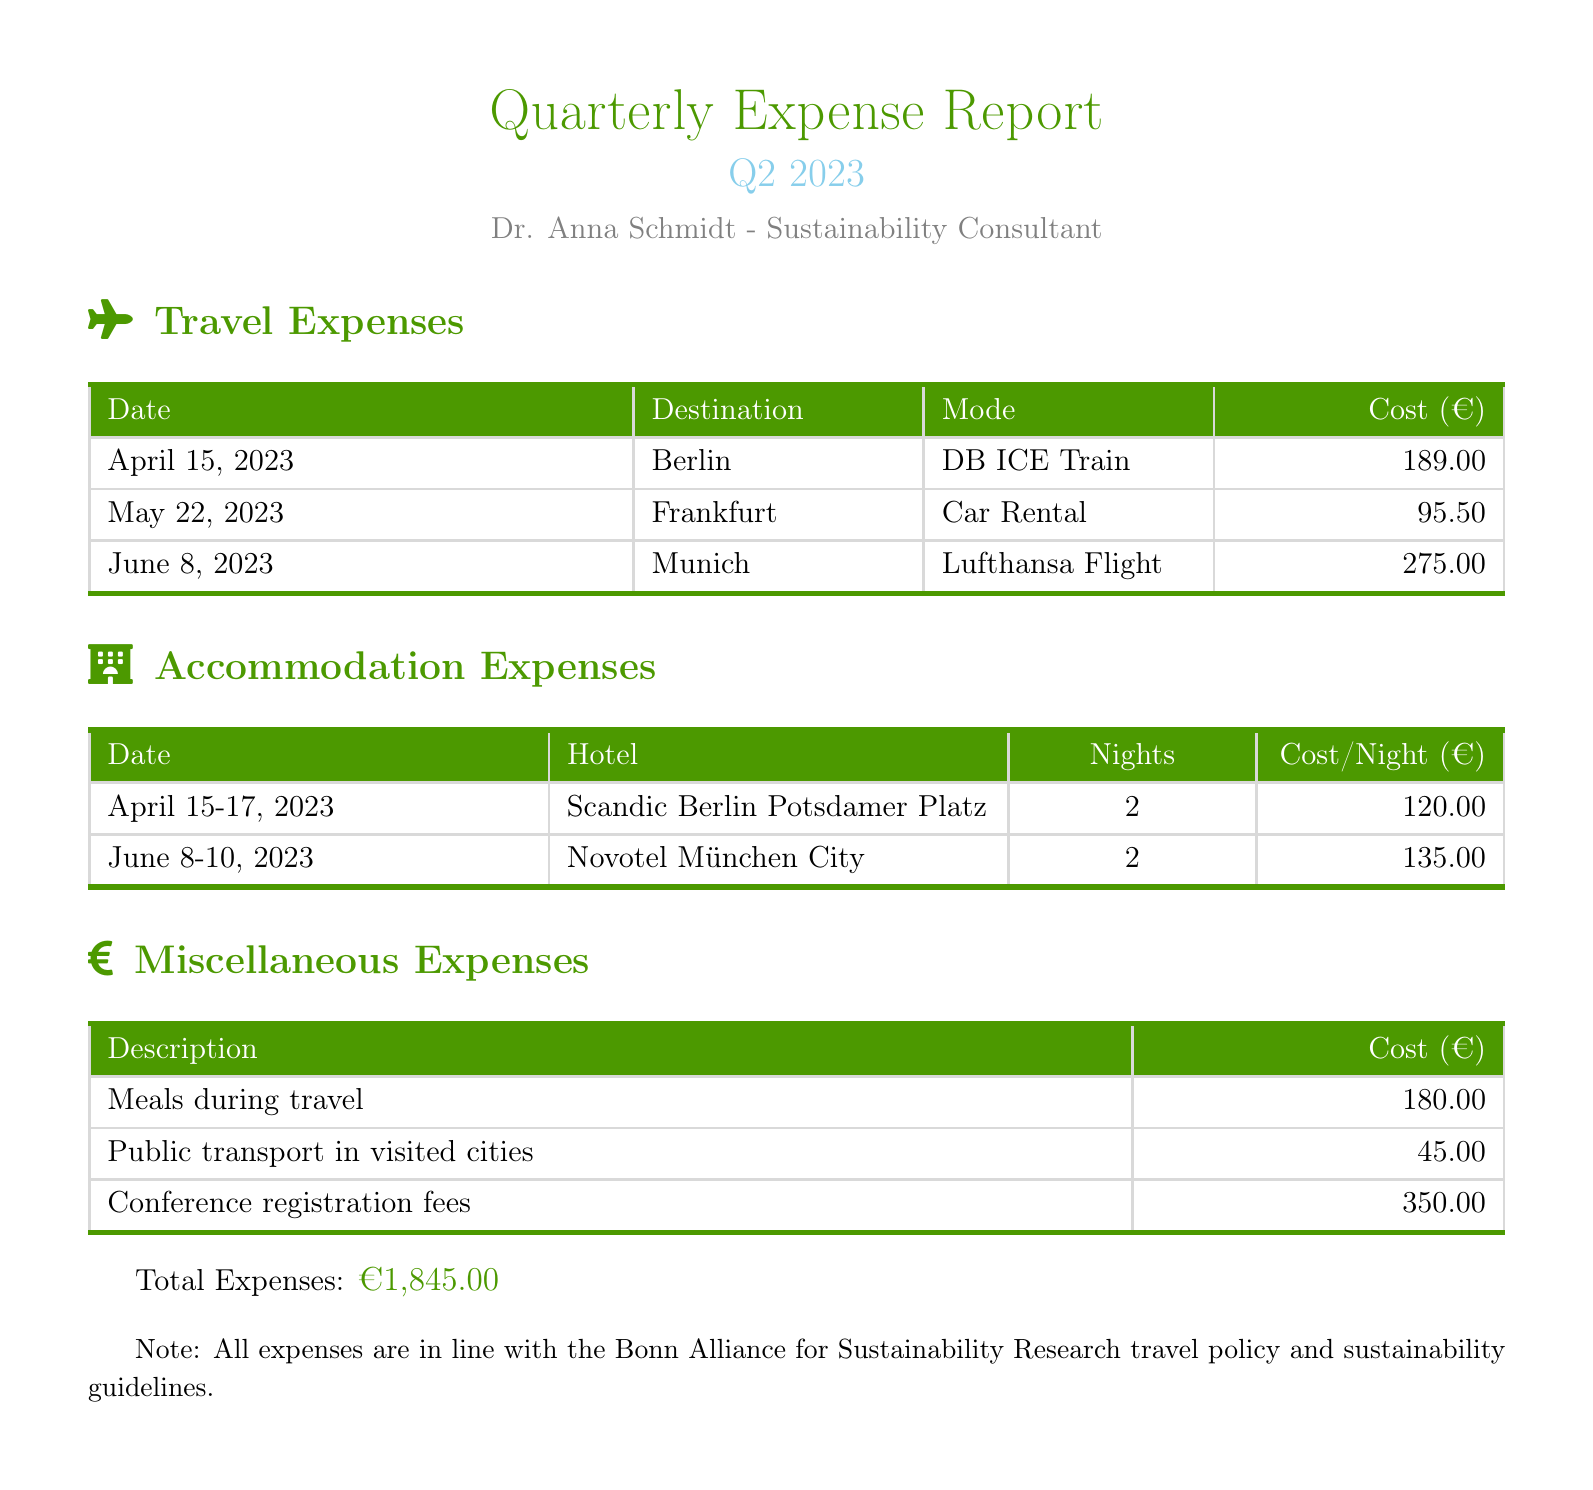What is the total cost of travel expenses? The total cost of travel expenses is the sum of all individual travel costs listed in the travel section: 189.00 + 95.50 + 275.00 = 559.50.
Answer: 559.00 What city was visited on April 15, 2023? April 15, 2023 is listed under the travel expenses for Berlin.
Answer: Berlin How many nights was accommodation booked in Munich? The accommodation section shows that 2 nights were booked for the hotel in Munich.
Answer: 2 What was the cost per night at the Novotel München City? The cost per night at Novotel München City is stated as 135.00.
Answer: 135.00 What was the total cost of miscellaneous expenses? The total cost of miscellaneous expenses is the sum of all costs listed under this section: 180.00 + 45.00 + 350.00 = 575.00.
Answer: 575.00 In which month did the most expensive travel expense occur? The highest individual travel expense listed is from June, specifically for the Lufthansa Flight.
Answer: June What was the total amount for accommodation expenses? The total amount for accommodation expenses is calculated by adding the costs of both hotel stays: 120.00 * 2 nights + 135.00 * 2 nights = 510.00.
Answer: 510.00 What conference fees are included in the miscellaneous expenses? The document lists conference registration fees totaling 350.00 within the miscellaneous expenses.
Answer: 350.00 What is the total expenses summary for the quarter? The total expenses summary is denoted at the end of the document, stating the overall amount expended during the quarter.
Answer: €1,845.00 